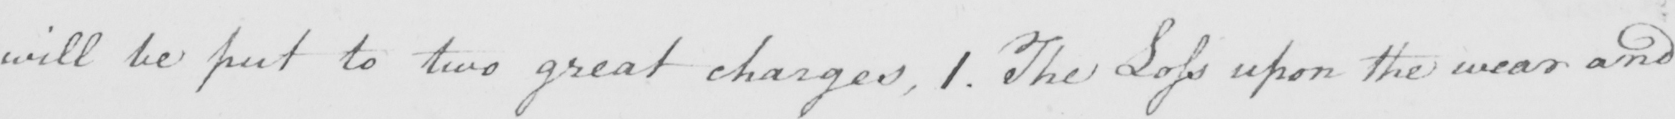Can you tell me what this handwritten text says? will be put to two great charges , 1 . The Loss upon the wear and 